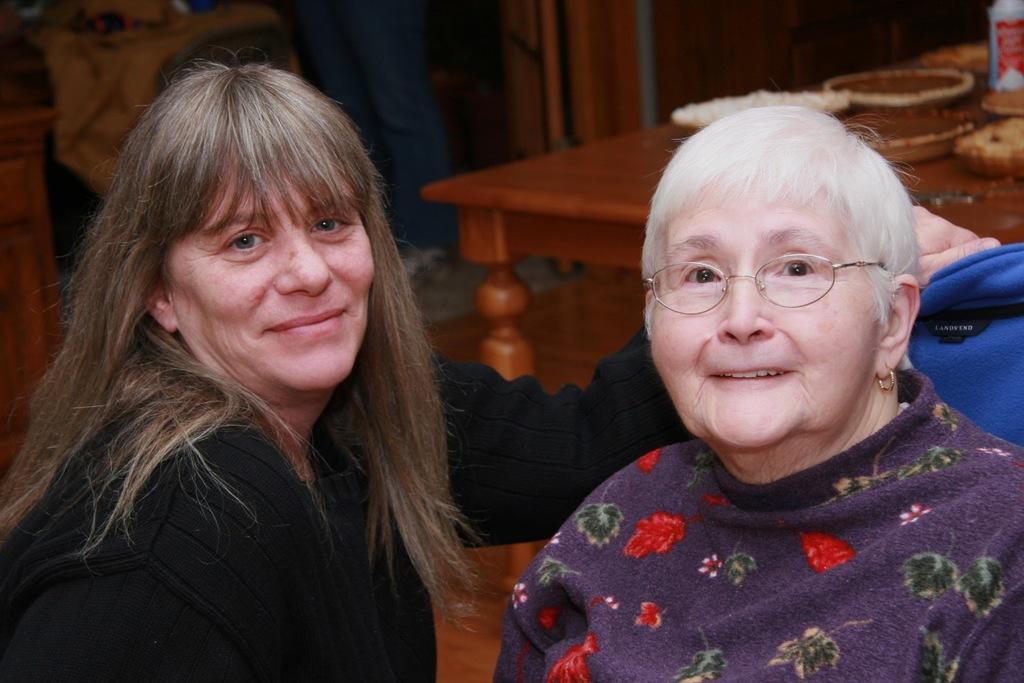Describe this image in one or two sentences. In this image I can see a two people smiling. Back Side I can see a bottle and something on the brown table. 